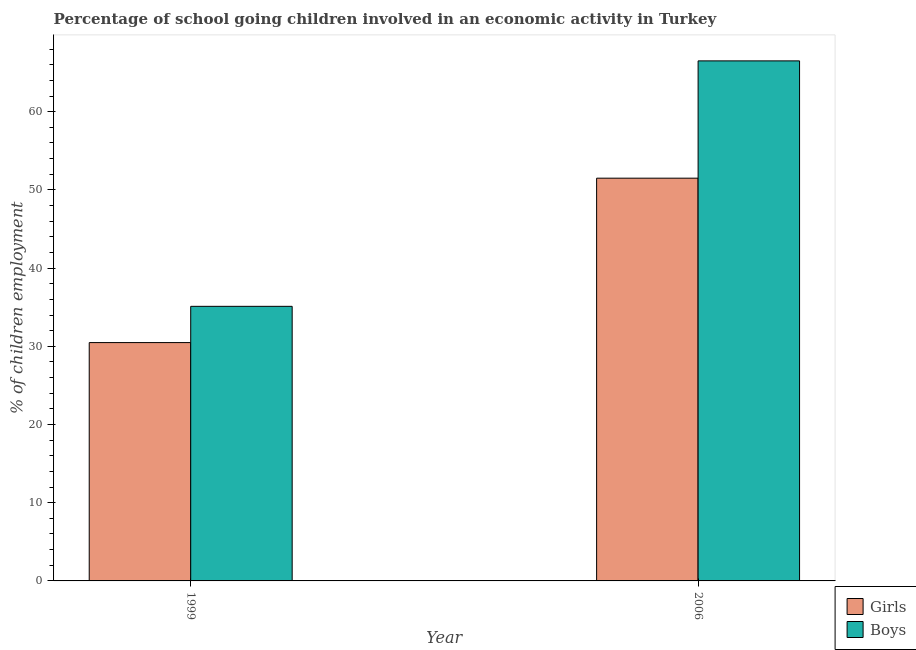How many groups of bars are there?
Ensure brevity in your answer.  2. How many bars are there on the 1st tick from the left?
Ensure brevity in your answer.  2. How many bars are there on the 1st tick from the right?
Your response must be concise. 2. What is the percentage of school going boys in 2006?
Provide a short and direct response. 66.5. Across all years, what is the maximum percentage of school going boys?
Give a very brief answer. 66.5. Across all years, what is the minimum percentage of school going boys?
Provide a succinct answer. 35.11. What is the total percentage of school going girls in the graph?
Provide a succinct answer. 81.98. What is the difference between the percentage of school going boys in 1999 and that in 2006?
Make the answer very short. -31.39. What is the difference between the percentage of school going boys in 2006 and the percentage of school going girls in 1999?
Make the answer very short. 31.39. What is the average percentage of school going girls per year?
Keep it short and to the point. 40.99. In how many years, is the percentage of school going boys greater than 30 %?
Offer a terse response. 2. What is the ratio of the percentage of school going boys in 1999 to that in 2006?
Offer a very short reply. 0.53. In how many years, is the percentage of school going girls greater than the average percentage of school going girls taken over all years?
Ensure brevity in your answer.  1. What does the 1st bar from the left in 2006 represents?
Give a very brief answer. Girls. What does the 1st bar from the right in 2006 represents?
Offer a very short reply. Boys. How many years are there in the graph?
Your answer should be compact. 2. Are the values on the major ticks of Y-axis written in scientific E-notation?
Provide a short and direct response. No. Does the graph contain any zero values?
Offer a very short reply. No. Does the graph contain grids?
Provide a succinct answer. No. Where does the legend appear in the graph?
Keep it short and to the point. Bottom right. How many legend labels are there?
Offer a terse response. 2. What is the title of the graph?
Your answer should be compact. Percentage of school going children involved in an economic activity in Turkey. Does "Exports" appear as one of the legend labels in the graph?
Offer a very short reply. No. What is the label or title of the X-axis?
Your answer should be very brief. Year. What is the label or title of the Y-axis?
Keep it short and to the point. % of children employment. What is the % of children employment in Girls in 1999?
Provide a short and direct response. 30.48. What is the % of children employment in Boys in 1999?
Your answer should be compact. 35.11. What is the % of children employment in Girls in 2006?
Your answer should be very brief. 51.5. What is the % of children employment in Boys in 2006?
Give a very brief answer. 66.5. Across all years, what is the maximum % of children employment of Girls?
Provide a succinct answer. 51.5. Across all years, what is the maximum % of children employment of Boys?
Give a very brief answer. 66.5. Across all years, what is the minimum % of children employment of Girls?
Your answer should be very brief. 30.48. Across all years, what is the minimum % of children employment of Boys?
Keep it short and to the point. 35.11. What is the total % of children employment in Girls in the graph?
Ensure brevity in your answer.  81.98. What is the total % of children employment in Boys in the graph?
Give a very brief answer. 101.61. What is the difference between the % of children employment of Girls in 1999 and that in 2006?
Your response must be concise. -21.02. What is the difference between the % of children employment in Boys in 1999 and that in 2006?
Provide a succinct answer. -31.39. What is the difference between the % of children employment of Girls in 1999 and the % of children employment of Boys in 2006?
Your answer should be very brief. -36.02. What is the average % of children employment of Girls per year?
Ensure brevity in your answer.  40.99. What is the average % of children employment of Boys per year?
Offer a very short reply. 50.81. In the year 1999, what is the difference between the % of children employment of Girls and % of children employment of Boys?
Ensure brevity in your answer.  -4.64. In the year 2006, what is the difference between the % of children employment of Girls and % of children employment of Boys?
Your response must be concise. -15. What is the ratio of the % of children employment of Girls in 1999 to that in 2006?
Your answer should be compact. 0.59. What is the ratio of the % of children employment in Boys in 1999 to that in 2006?
Your response must be concise. 0.53. What is the difference between the highest and the second highest % of children employment of Girls?
Make the answer very short. 21.02. What is the difference between the highest and the second highest % of children employment of Boys?
Provide a succinct answer. 31.39. What is the difference between the highest and the lowest % of children employment in Girls?
Your response must be concise. 21.02. What is the difference between the highest and the lowest % of children employment of Boys?
Give a very brief answer. 31.39. 